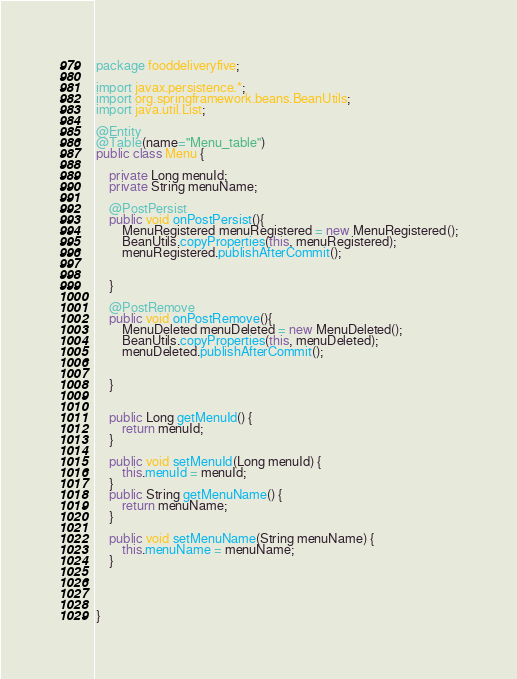Convert code to text. <code><loc_0><loc_0><loc_500><loc_500><_Java_>package fooddeliveryfive;

import javax.persistence.*;
import org.springframework.beans.BeanUtils;
import java.util.List;

@Entity
@Table(name="Menu_table")
public class Menu {

    private Long menuId;
    private String menuName;

    @PostPersist
    public void onPostPersist(){
        MenuRegistered menuRegistered = new MenuRegistered();
        BeanUtils.copyProperties(this, menuRegistered);
        menuRegistered.publishAfterCommit();


    }

    @PostRemove
    public void onPostRemove(){
        MenuDeleted menuDeleted = new MenuDeleted();
        BeanUtils.copyProperties(this, menuDeleted);
        menuDeleted.publishAfterCommit();


    }


    public Long getMenuId() {
        return menuId;
    }

    public void setMenuId(Long menuId) {
        this.menuId = menuId;
    }
    public String getMenuName() {
        return menuName;
    }

    public void setMenuName(String menuName) {
        this.menuName = menuName;
    }




}
</code> 